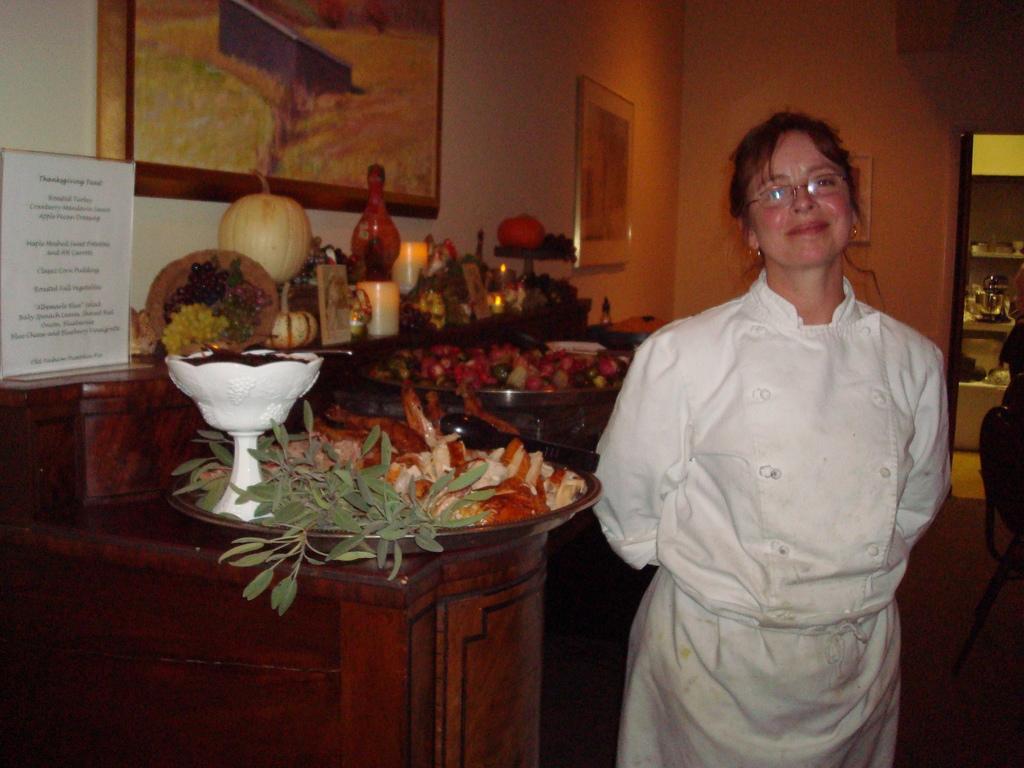Please provide a concise description of this image. In this image I can see a woman wearing white colored dress is stunning. I can see a huge plate with few objects which are green, cream and brown in color and a white colored bowl with few objects in it. I can see few fruits, few candles, the wall, few photo frames attached to the wall, a white colored board, the door and few other objects through the door. To the right side of the image I can see a chair. 